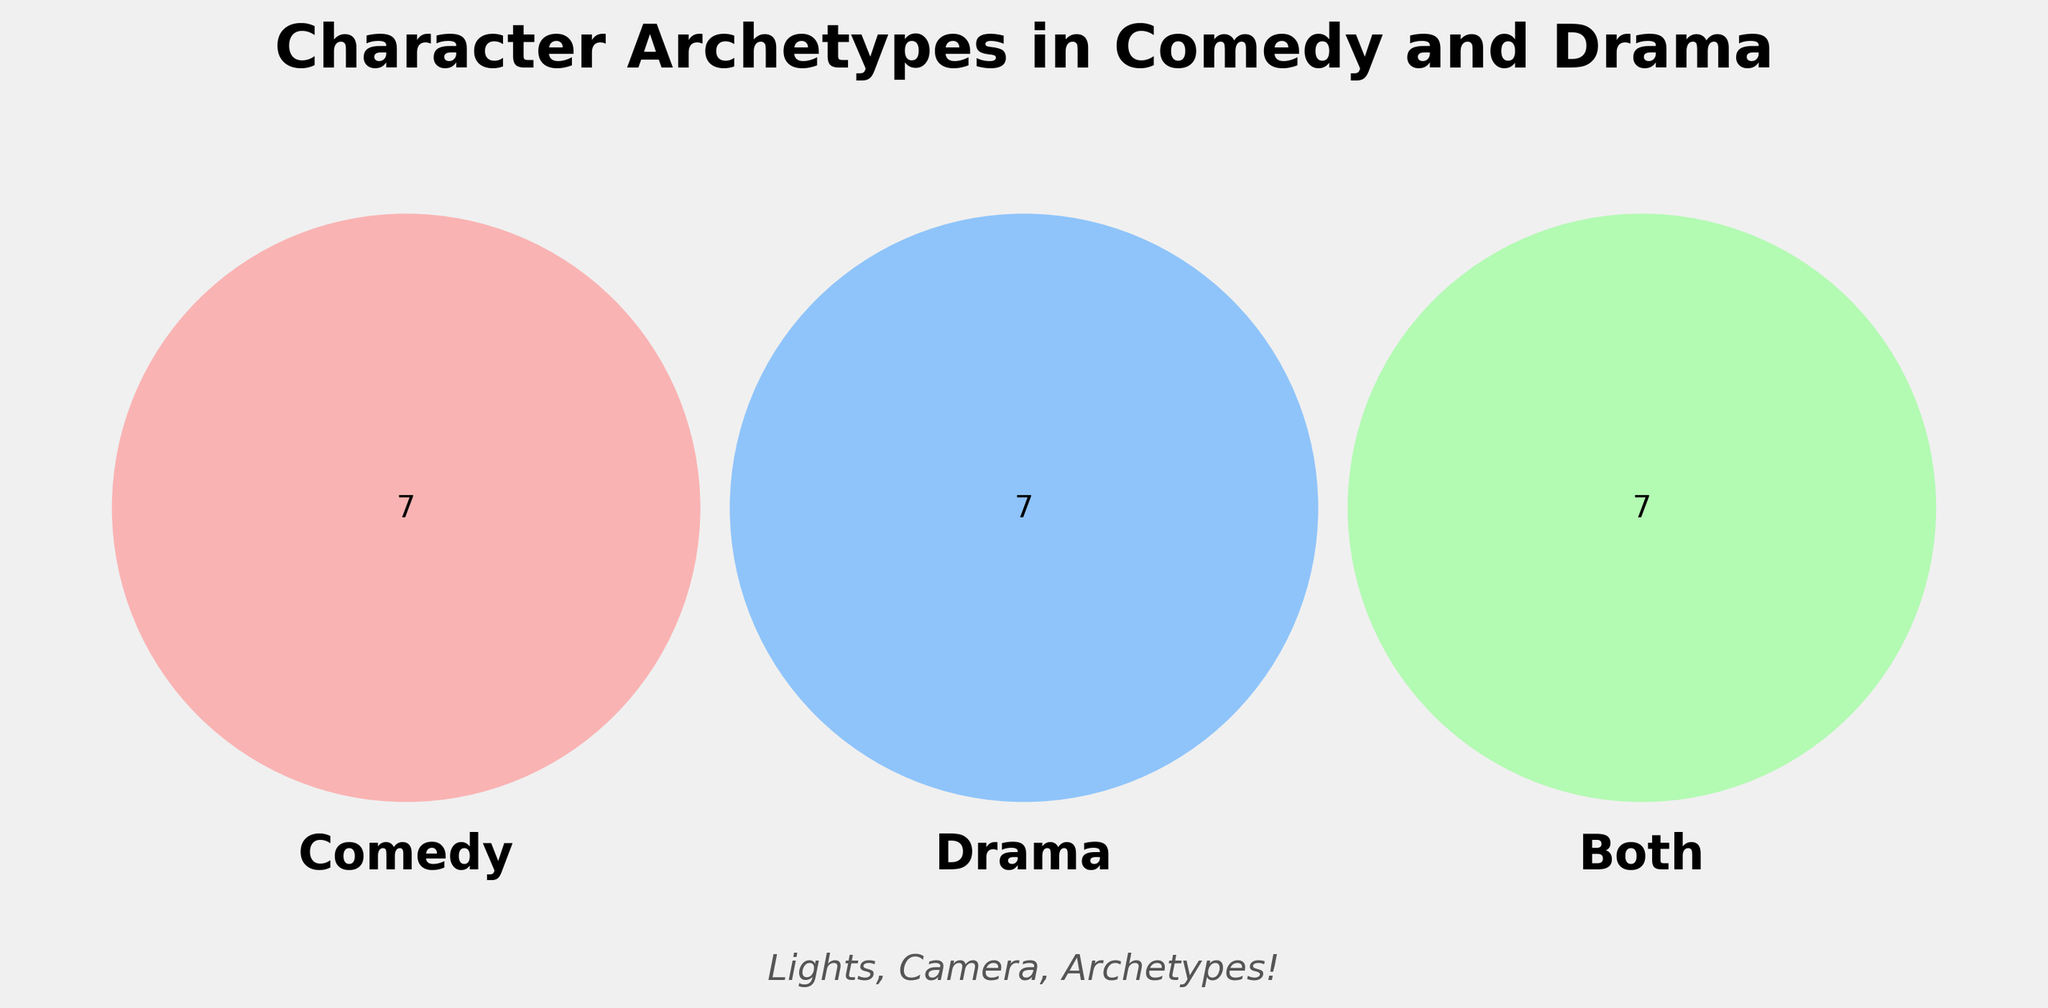What is the title of the Venn Diagram? The title is usually at the top of the figure and clearly labels what it represents. In this case, it is likely to be something descriptive.
Answer: Character Archetypes in Comedy and Drama Which group contains the 'Trickster' character archetype? By looking at the section labeled "Comedy," you can find the 'Trickster' archetype under this category.
Answer: Comedy Which character archetypes are shared between comedy and drama? The 'Both' section indicates which archetypes are common to both genres.
Answer: Underdog, Love interest, Protagonist, Eccentric genius, Reluctant hero, Flawed hero, Everyman/Everywoman How many character archetypes are unique to drama? By counting the archetypes listed under the 'Drama' category, you can determine the count.
Answer: Seven Are there more unique archetypes in comedy or drama? Compare the number of unique archetypes in the 'Comedy' and 'Drama' sections. Comedy has seven, and Drama has seven as well.
Answer: They have an equal number Which section contains the 'Brooding antihero'? Locate the 'Brooding antihero' within either the 'Comedy,' 'Drama,' or 'Both' sections.
Answer: Drama Which section shows the highest number of archetypes? Count the number of archetypes in the sections 'Comedy,' 'Drama,' and 'Both'. The 'Both' section has seven archetypes.
Answer: Both Are 'Mentor figures' shared between comedy and drama? Check if 'Mentor figures' appear in the 'Both' section where shared archetypes are listed.
Answer: No What is the total number of unique character archetypes in comedy and drama combined? Add the number of unique archetypes in 'Comedy' and 'Drama'.
Answer: Fourteen Is the 'Love interest' archetype exclusive to any genre? Find 'Love interest' in the 'Both' section, indicating it is shared and not exclusive.
Answer: No 